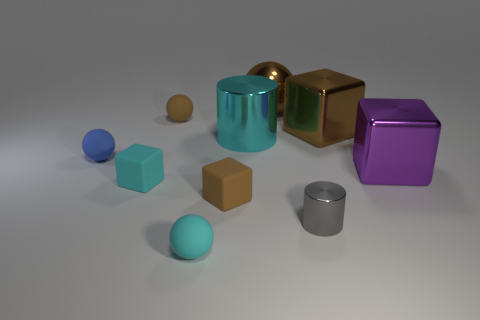What number of purple objects are the same shape as the cyan metallic thing?
Provide a short and direct response. 0. There is a metal object in front of the brown matte block; how many matte balls are to the right of it?
Offer a terse response. 0. How many metal objects are small blocks or cyan things?
Your answer should be compact. 1. Are there any large purple cylinders made of the same material as the large sphere?
Make the answer very short. No. How many things are cylinders behind the blue sphere or large cylinders left of the gray object?
Provide a succinct answer. 1. There is a block behind the cyan metallic cylinder; is it the same color as the tiny cylinder?
Your response must be concise. No. How many other things are the same color as the tiny metal thing?
Give a very brief answer. 0. What material is the cyan block?
Provide a short and direct response. Rubber. Does the metal cylinder in front of the blue matte sphere have the same size as the blue sphere?
Give a very brief answer. Yes. Is there any other thing that is the same size as the blue sphere?
Make the answer very short. Yes. 